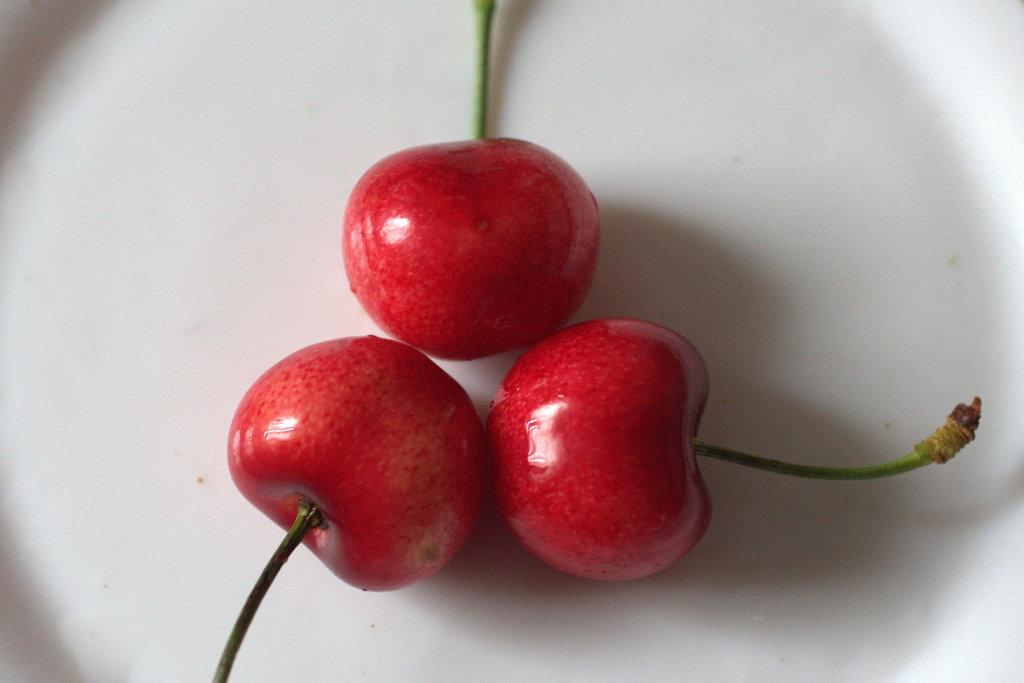What color are the fruits in the image? The fruits in the image are red. How many fruits can be seen in the image? There are three red fruits in the image. What is the surface on which the fruits are placed? The fruits are on a white surface. What page of the book does the volleyball appear on in the image? There is no book or volleyball present in the image; it only features three red fruits on a white surface. 